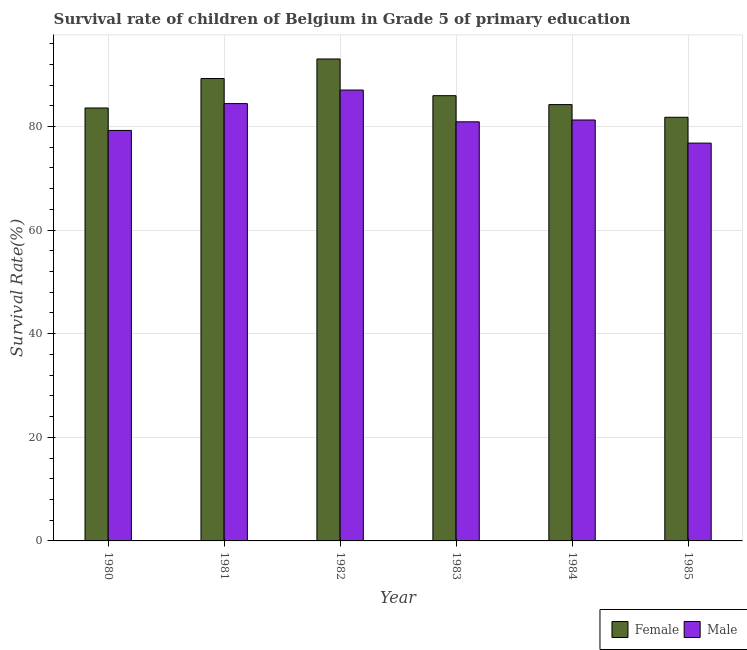How many different coloured bars are there?
Provide a short and direct response. 2. Are the number of bars per tick equal to the number of legend labels?
Provide a succinct answer. Yes. How many bars are there on the 1st tick from the left?
Ensure brevity in your answer.  2. How many bars are there on the 2nd tick from the right?
Provide a short and direct response. 2. In how many cases, is the number of bars for a given year not equal to the number of legend labels?
Offer a very short reply. 0. What is the survival rate of female students in primary education in 1982?
Offer a terse response. 93.02. Across all years, what is the maximum survival rate of male students in primary education?
Provide a short and direct response. 87.03. Across all years, what is the minimum survival rate of male students in primary education?
Your answer should be compact. 76.79. In which year was the survival rate of male students in primary education maximum?
Give a very brief answer. 1982. What is the total survival rate of male students in primary education in the graph?
Make the answer very short. 489.59. What is the difference between the survival rate of female students in primary education in 1984 and that in 1985?
Your answer should be very brief. 2.45. What is the difference between the survival rate of female students in primary education in 1984 and the survival rate of male students in primary education in 1983?
Provide a short and direct response. -1.72. What is the average survival rate of female students in primary education per year?
Provide a succinct answer. 86.3. In the year 1984, what is the difference between the survival rate of male students in primary education and survival rate of female students in primary education?
Provide a short and direct response. 0. What is the ratio of the survival rate of female students in primary education in 1984 to that in 1985?
Give a very brief answer. 1.03. Is the survival rate of female students in primary education in 1983 less than that in 1984?
Ensure brevity in your answer.  No. Is the difference between the survival rate of male students in primary education in 1980 and 1983 greater than the difference between the survival rate of female students in primary education in 1980 and 1983?
Your response must be concise. No. What is the difference between the highest and the second highest survival rate of female students in primary education?
Your answer should be compact. 3.77. What is the difference between the highest and the lowest survival rate of male students in primary education?
Give a very brief answer. 10.24. Is the sum of the survival rate of female students in primary education in 1984 and 1985 greater than the maximum survival rate of male students in primary education across all years?
Your response must be concise. Yes. What does the 1st bar from the right in 1983 represents?
Your answer should be very brief. Male. Are all the bars in the graph horizontal?
Provide a short and direct response. No. How many years are there in the graph?
Keep it short and to the point. 6. What is the title of the graph?
Your answer should be very brief. Survival rate of children of Belgium in Grade 5 of primary education. Does "Highest 10% of population" appear as one of the legend labels in the graph?
Your response must be concise. No. What is the label or title of the Y-axis?
Keep it short and to the point. Survival Rate(%). What is the Survival Rate(%) in Female in 1980?
Make the answer very short. 83.57. What is the Survival Rate(%) of Male in 1980?
Your response must be concise. 79.23. What is the Survival Rate(%) of Female in 1981?
Offer a very short reply. 89.25. What is the Survival Rate(%) of Male in 1981?
Provide a succinct answer. 84.41. What is the Survival Rate(%) of Female in 1982?
Your answer should be very brief. 93.02. What is the Survival Rate(%) of Male in 1982?
Provide a succinct answer. 87.03. What is the Survival Rate(%) of Female in 1983?
Your response must be concise. 85.94. What is the Survival Rate(%) of Male in 1983?
Your answer should be very brief. 80.89. What is the Survival Rate(%) of Female in 1984?
Offer a very short reply. 84.22. What is the Survival Rate(%) of Male in 1984?
Your answer should be very brief. 81.25. What is the Survival Rate(%) in Female in 1985?
Ensure brevity in your answer.  81.77. What is the Survival Rate(%) in Male in 1985?
Your answer should be very brief. 76.79. Across all years, what is the maximum Survival Rate(%) in Female?
Your answer should be compact. 93.02. Across all years, what is the maximum Survival Rate(%) in Male?
Your response must be concise. 87.03. Across all years, what is the minimum Survival Rate(%) in Female?
Give a very brief answer. 81.77. Across all years, what is the minimum Survival Rate(%) in Male?
Your response must be concise. 76.79. What is the total Survival Rate(%) in Female in the graph?
Your answer should be very brief. 517.77. What is the total Survival Rate(%) of Male in the graph?
Give a very brief answer. 489.59. What is the difference between the Survival Rate(%) of Female in 1980 and that in 1981?
Make the answer very short. -5.69. What is the difference between the Survival Rate(%) in Male in 1980 and that in 1981?
Offer a terse response. -5.18. What is the difference between the Survival Rate(%) of Female in 1980 and that in 1982?
Provide a succinct answer. -9.46. What is the difference between the Survival Rate(%) of Male in 1980 and that in 1982?
Provide a succinct answer. -7.8. What is the difference between the Survival Rate(%) in Female in 1980 and that in 1983?
Keep it short and to the point. -2.37. What is the difference between the Survival Rate(%) in Male in 1980 and that in 1983?
Keep it short and to the point. -1.67. What is the difference between the Survival Rate(%) of Female in 1980 and that in 1984?
Keep it short and to the point. -0.65. What is the difference between the Survival Rate(%) in Male in 1980 and that in 1984?
Ensure brevity in your answer.  -2.02. What is the difference between the Survival Rate(%) of Female in 1980 and that in 1985?
Give a very brief answer. 1.8. What is the difference between the Survival Rate(%) of Male in 1980 and that in 1985?
Your response must be concise. 2.44. What is the difference between the Survival Rate(%) of Female in 1981 and that in 1982?
Ensure brevity in your answer.  -3.77. What is the difference between the Survival Rate(%) of Male in 1981 and that in 1982?
Your answer should be compact. -2.62. What is the difference between the Survival Rate(%) of Female in 1981 and that in 1983?
Keep it short and to the point. 3.31. What is the difference between the Survival Rate(%) of Male in 1981 and that in 1983?
Ensure brevity in your answer.  3.52. What is the difference between the Survival Rate(%) of Female in 1981 and that in 1984?
Offer a very short reply. 5.03. What is the difference between the Survival Rate(%) of Male in 1981 and that in 1984?
Your answer should be very brief. 3.16. What is the difference between the Survival Rate(%) in Female in 1981 and that in 1985?
Your answer should be compact. 7.48. What is the difference between the Survival Rate(%) of Male in 1981 and that in 1985?
Make the answer very short. 7.63. What is the difference between the Survival Rate(%) of Female in 1982 and that in 1983?
Provide a short and direct response. 7.08. What is the difference between the Survival Rate(%) of Male in 1982 and that in 1983?
Your answer should be compact. 6.13. What is the difference between the Survival Rate(%) of Female in 1982 and that in 1984?
Your answer should be very brief. 8.81. What is the difference between the Survival Rate(%) of Male in 1982 and that in 1984?
Keep it short and to the point. 5.78. What is the difference between the Survival Rate(%) in Female in 1982 and that in 1985?
Give a very brief answer. 11.25. What is the difference between the Survival Rate(%) in Male in 1982 and that in 1985?
Keep it short and to the point. 10.24. What is the difference between the Survival Rate(%) in Female in 1983 and that in 1984?
Give a very brief answer. 1.72. What is the difference between the Survival Rate(%) in Male in 1983 and that in 1984?
Keep it short and to the point. -0.35. What is the difference between the Survival Rate(%) of Female in 1983 and that in 1985?
Your answer should be very brief. 4.17. What is the difference between the Survival Rate(%) of Male in 1983 and that in 1985?
Your response must be concise. 4.11. What is the difference between the Survival Rate(%) of Female in 1984 and that in 1985?
Ensure brevity in your answer.  2.45. What is the difference between the Survival Rate(%) in Male in 1984 and that in 1985?
Offer a terse response. 4.46. What is the difference between the Survival Rate(%) in Female in 1980 and the Survival Rate(%) in Male in 1981?
Your answer should be very brief. -0.85. What is the difference between the Survival Rate(%) in Female in 1980 and the Survival Rate(%) in Male in 1982?
Offer a terse response. -3.46. What is the difference between the Survival Rate(%) in Female in 1980 and the Survival Rate(%) in Male in 1983?
Provide a short and direct response. 2.67. What is the difference between the Survival Rate(%) in Female in 1980 and the Survival Rate(%) in Male in 1984?
Your answer should be very brief. 2.32. What is the difference between the Survival Rate(%) of Female in 1980 and the Survival Rate(%) of Male in 1985?
Ensure brevity in your answer.  6.78. What is the difference between the Survival Rate(%) in Female in 1981 and the Survival Rate(%) in Male in 1982?
Offer a terse response. 2.22. What is the difference between the Survival Rate(%) of Female in 1981 and the Survival Rate(%) of Male in 1983?
Provide a succinct answer. 8.36. What is the difference between the Survival Rate(%) in Female in 1981 and the Survival Rate(%) in Male in 1984?
Your response must be concise. 8. What is the difference between the Survival Rate(%) in Female in 1981 and the Survival Rate(%) in Male in 1985?
Your response must be concise. 12.47. What is the difference between the Survival Rate(%) of Female in 1982 and the Survival Rate(%) of Male in 1983?
Provide a succinct answer. 12.13. What is the difference between the Survival Rate(%) of Female in 1982 and the Survival Rate(%) of Male in 1984?
Keep it short and to the point. 11.78. What is the difference between the Survival Rate(%) of Female in 1982 and the Survival Rate(%) of Male in 1985?
Your response must be concise. 16.24. What is the difference between the Survival Rate(%) of Female in 1983 and the Survival Rate(%) of Male in 1984?
Provide a succinct answer. 4.69. What is the difference between the Survival Rate(%) in Female in 1983 and the Survival Rate(%) in Male in 1985?
Your response must be concise. 9.15. What is the difference between the Survival Rate(%) of Female in 1984 and the Survival Rate(%) of Male in 1985?
Make the answer very short. 7.43. What is the average Survival Rate(%) of Female per year?
Your answer should be compact. 86.3. What is the average Survival Rate(%) in Male per year?
Make the answer very short. 81.6. In the year 1980, what is the difference between the Survival Rate(%) of Female and Survival Rate(%) of Male?
Your response must be concise. 4.34. In the year 1981, what is the difference between the Survival Rate(%) of Female and Survival Rate(%) of Male?
Your answer should be very brief. 4.84. In the year 1982, what is the difference between the Survival Rate(%) of Female and Survival Rate(%) of Male?
Your answer should be compact. 6. In the year 1983, what is the difference between the Survival Rate(%) in Female and Survival Rate(%) in Male?
Ensure brevity in your answer.  5.05. In the year 1984, what is the difference between the Survival Rate(%) in Female and Survival Rate(%) in Male?
Give a very brief answer. 2.97. In the year 1985, what is the difference between the Survival Rate(%) of Female and Survival Rate(%) of Male?
Your answer should be very brief. 4.98. What is the ratio of the Survival Rate(%) in Female in 1980 to that in 1981?
Provide a short and direct response. 0.94. What is the ratio of the Survival Rate(%) in Male in 1980 to that in 1981?
Offer a terse response. 0.94. What is the ratio of the Survival Rate(%) in Female in 1980 to that in 1982?
Your answer should be compact. 0.9. What is the ratio of the Survival Rate(%) of Male in 1980 to that in 1982?
Offer a terse response. 0.91. What is the ratio of the Survival Rate(%) in Female in 1980 to that in 1983?
Ensure brevity in your answer.  0.97. What is the ratio of the Survival Rate(%) of Male in 1980 to that in 1983?
Make the answer very short. 0.98. What is the ratio of the Survival Rate(%) in Male in 1980 to that in 1984?
Your answer should be very brief. 0.98. What is the ratio of the Survival Rate(%) of Male in 1980 to that in 1985?
Your answer should be very brief. 1.03. What is the ratio of the Survival Rate(%) in Female in 1981 to that in 1982?
Provide a short and direct response. 0.96. What is the ratio of the Survival Rate(%) in Male in 1981 to that in 1982?
Make the answer very short. 0.97. What is the ratio of the Survival Rate(%) of Female in 1981 to that in 1983?
Your answer should be compact. 1.04. What is the ratio of the Survival Rate(%) of Male in 1981 to that in 1983?
Offer a very short reply. 1.04. What is the ratio of the Survival Rate(%) of Female in 1981 to that in 1984?
Your answer should be very brief. 1.06. What is the ratio of the Survival Rate(%) of Male in 1981 to that in 1984?
Offer a very short reply. 1.04. What is the ratio of the Survival Rate(%) of Female in 1981 to that in 1985?
Give a very brief answer. 1.09. What is the ratio of the Survival Rate(%) in Male in 1981 to that in 1985?
Provide a succinct answer. 1.1. What is the ratio of the Survival Rate(%) in Female in 1982 to that in 1983?
Your answer should be very brief. 1.08. What is the ratio of the Survival Rate(%) of Male in 1982 to that in 1983?
Ensure brevity in your answer.  1.08. What is the ratio of the Survival Rate(%) in Female in 1982 to that in 1984?
Provide a short and direct response. 1.1. What is the ratio of the Survival Rate(%) in Male in 1982 to that in 1984?
Make the answer very short. 1.07. What is the ratio of the Survival Rate(%) of Female in 1982 to that in 1985?
Offer a terse response. 1.14. What is the ratio of the Survival Rate(%) in Male in 1982 to that in 1985?
Provide a succinct answer. 1.13. What is the ratio of the Survival Rate(%) in Female in 1983 to that in 1984?
Make the answer very short. 1.02. What is the ratio of the Survival Rate(%) in Male in 1983 to that in 1984?
Ensure brevity in your answer.  1. What is the ratio of the Survival Rate(%) in Female in 1983 to that in 1985?
Offer a terse response. 1.05. What is the ratio of the Survival Rate(%) of Male in 1983 to that in 1985?
Provide a short and direct response. 1.05. What is the ratio of the Survival Rate(%) of Female in 1984 to that in 1985?
Keep it short and to the point. 1.03. What is the ratio of the Survival Rate(%) of Male in 1984 to that in 1985?
Offer a terse response. 1.06. What is the difference between the highest and the second highest Survival Rate(%) of Female?
Offer a very short reply. 3.77. What is the difference between the highest and the second highest Survival Rate(%) of Male?
Offer a terse response. 2.62. What is the difference between the highest and the lowest Survival Rate(%) of Female?
Your answer should be very brief. 11.25. What is the difference between the highest and the lowest Survival Rate(%) of Male?
Provide a short and direct response. 10.24. 